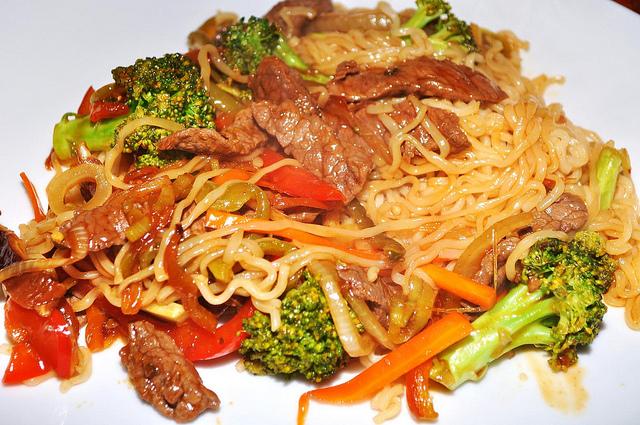Are noodles present?
Be succinct. Yes. What color is the plate?
Quick response, please. White. What vegetable is green in this dish?
Short answer required. Broccoli. 